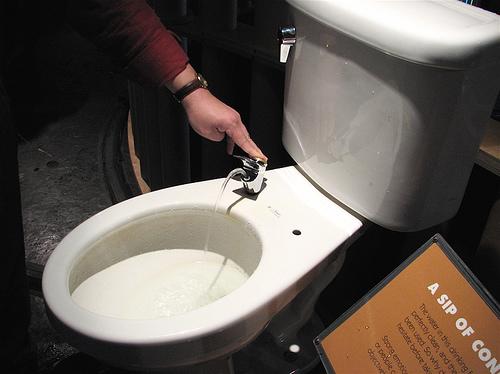What is the person doing?
Answer briefly. Pushing button. What color is the toilet?
Concise answer only. White. Is this a normal toilet?
Write a very short answer. No. 